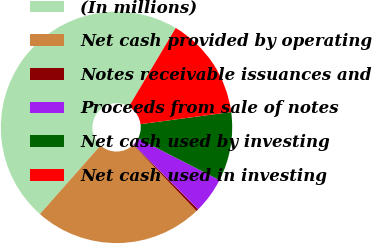Convert chart to OTSL. <chart><loc_0><loc_0><loc_500><loc_500><pie_chart><fcel>(In millions)<fcel>Net cash provided by operating<fcel>Notes receivable issuances and<fcel>Proceeds from sale of notes<fcel>Net cash used by investing<fcel>Net cash used in investing<nl><fcel>47.03%<fcel>23.67%<fcel>0.32%<fcel>4.99%<fcel>9.66%<fcel>14.33%<nl></chart> 